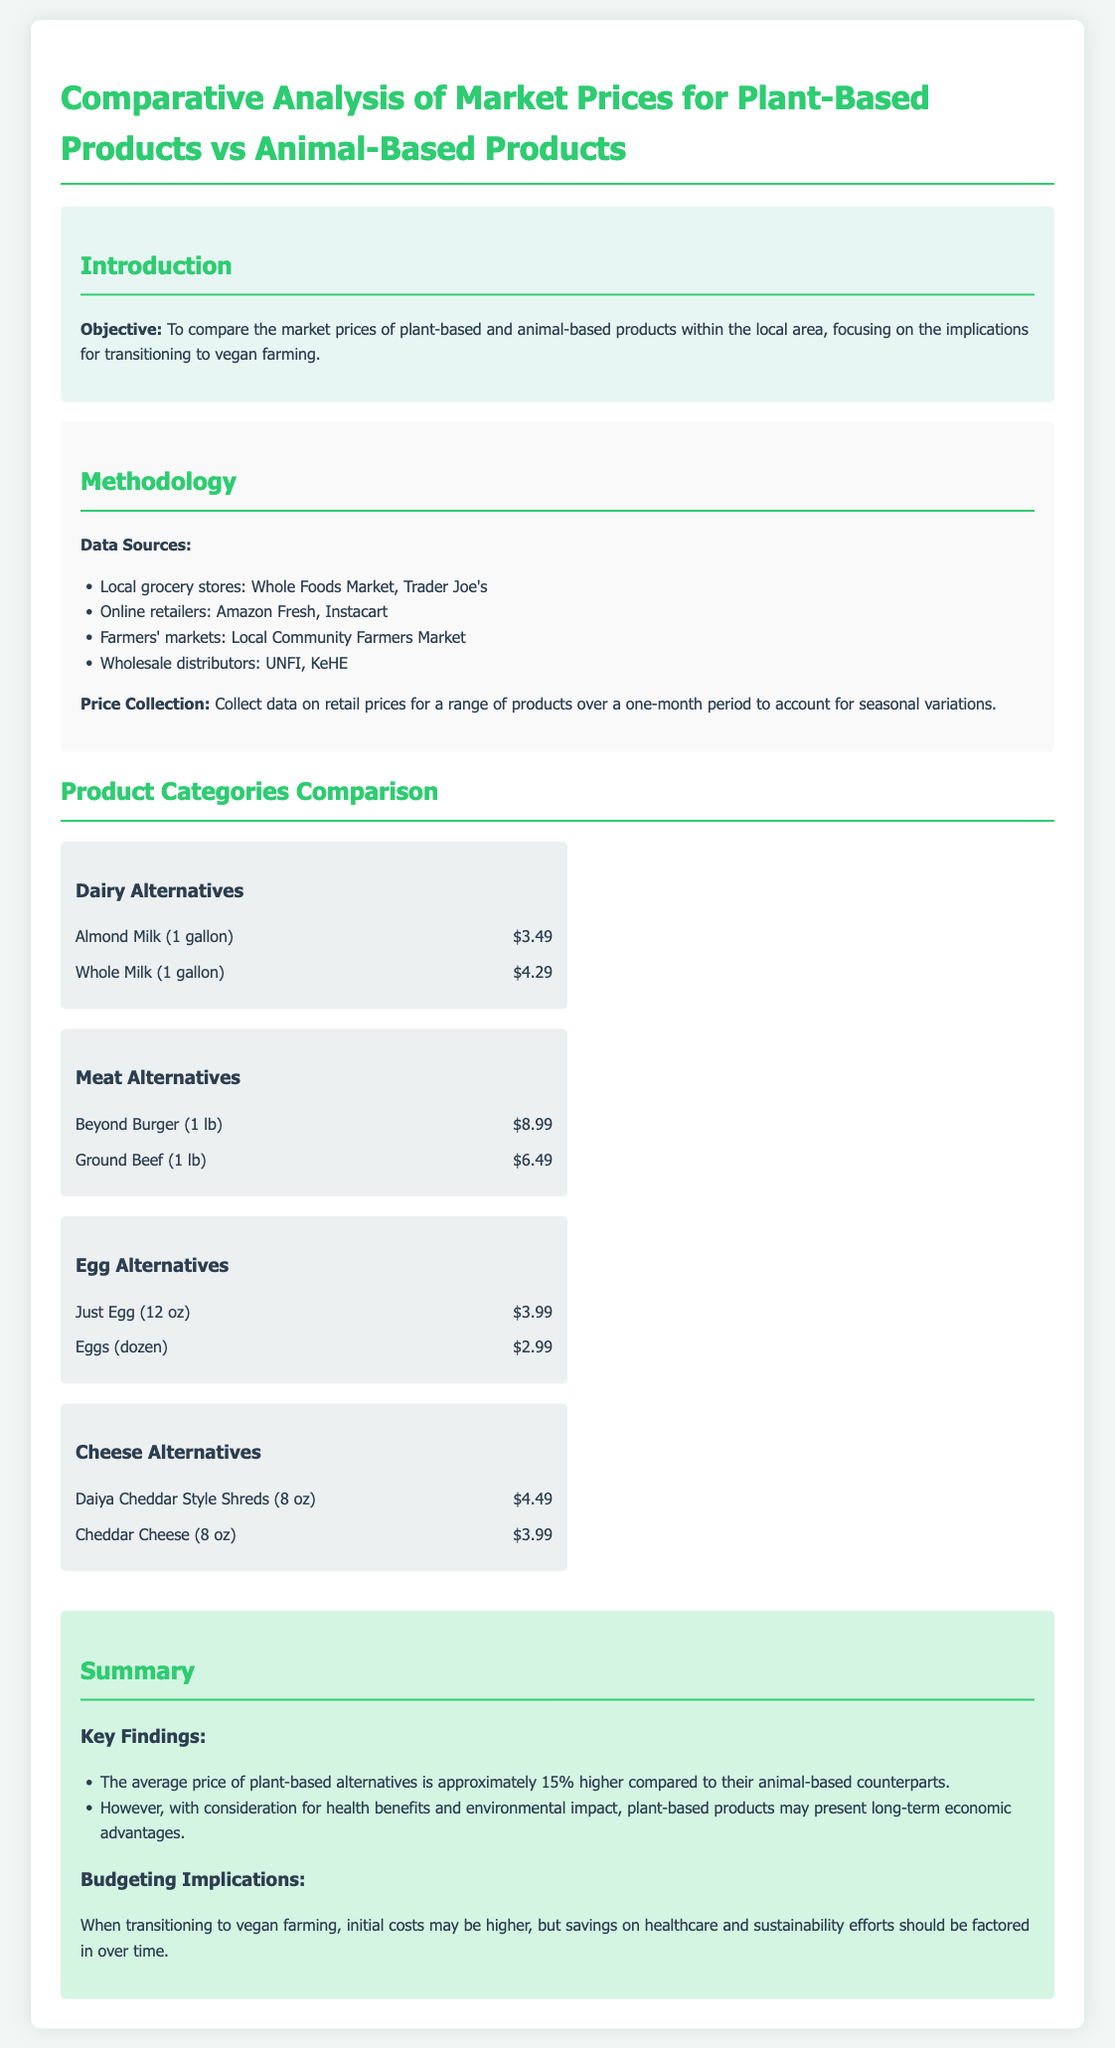What is the objective of the document? The document's objective is to compare the market prices of plant-based and animal-based products within the local area.
Answer: To compare market prices What is the price of almond milk? The price of almond milk is listed in the dairy alternatives section.
Answer: $3.49 Which alternative product is priced at $8.99? The product priced at $8.99 is mentioned in the meat alternatives section.
Answer: Beyond Burger How much do eggs cost per dozen? Eggs' price is provided in the egg alternatives section.
Answer: $2.99 What percentage higher are plant-based alternatives on average compared to animal-based alternatives? The document states this average difference in the summary section.
Answer: Approximately 15% What benefits of plant-based products are mentioned? The summary discusses both health benefits and environmental impact as advantages.
Answer: Health benefits and environmental impact What is the suggested implication for budgeting during the transition to vegan farming? The document suggests that initial costs may be higher but should be weighed against long-term savings.
Answer: Initial costs may be higher Which grocery store is listed as a data source? The document lists several data sources in the methodology section, one of which is named here.
Answer: Whole Foods Market What is the price of cheddar cheese? The price of cheddar cheese is found in the cheese alternatives section.
Answer: $3.99 